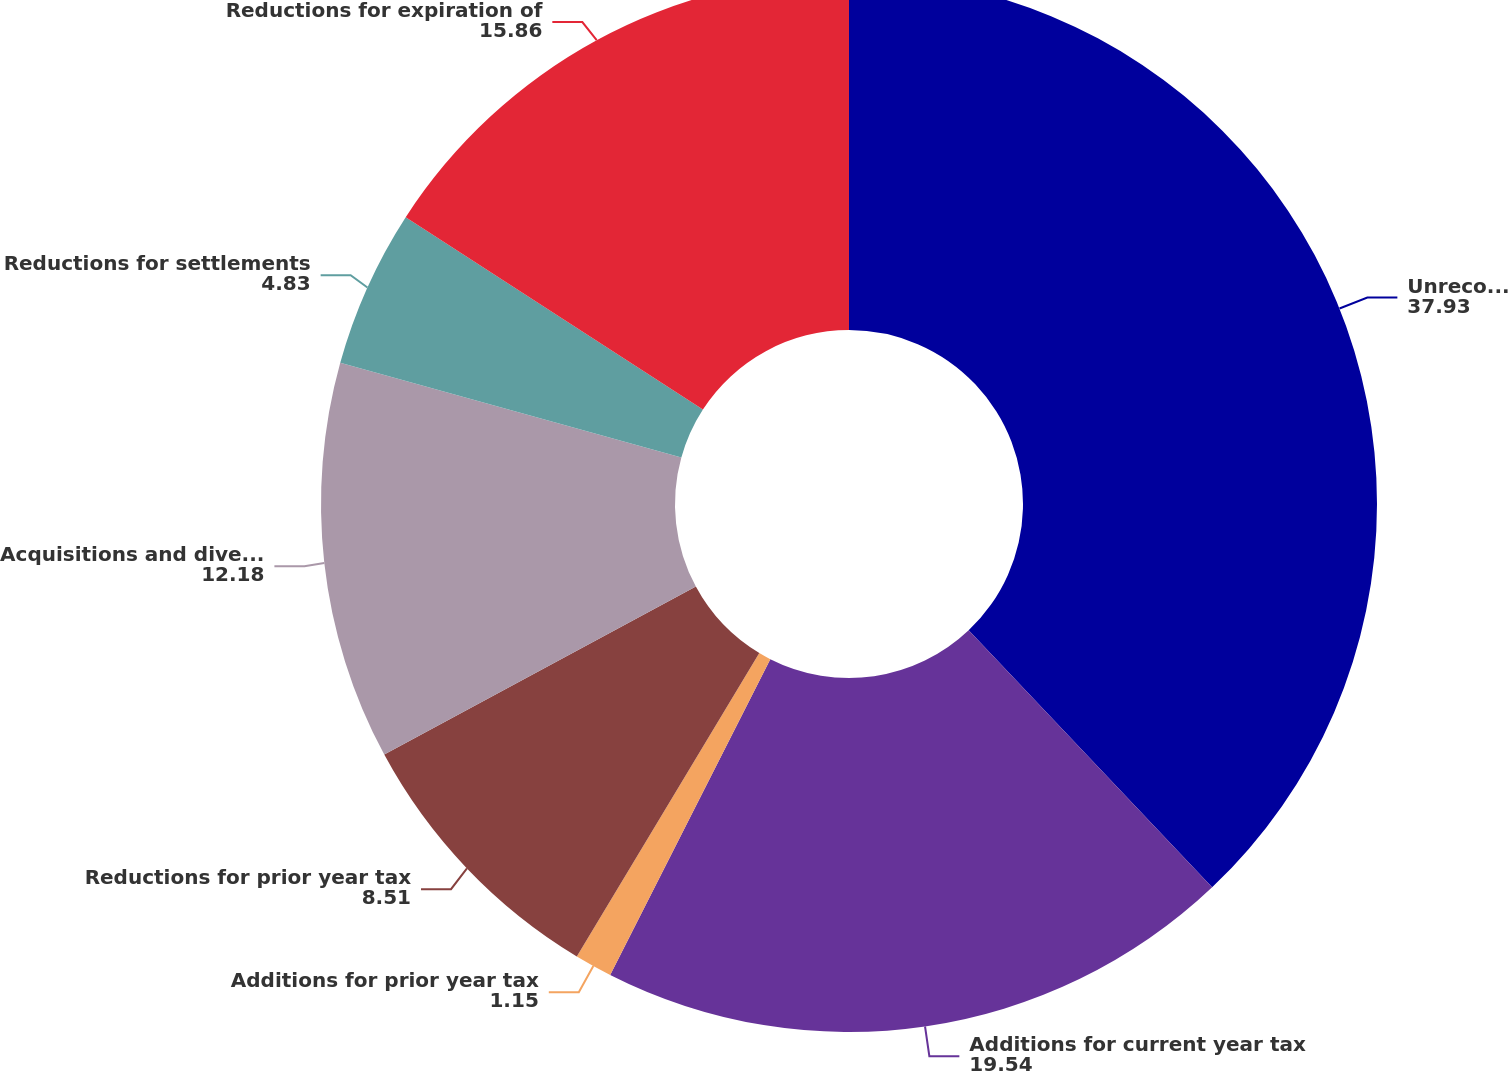<chart> <loc_0><loc_0><loc_500><loc_500><pie_chart><fcel>Unrecognized tax benefits<fcel>Additions for current year tax<fcel>Additions for prior year tax<fcel>Reductions for prior year tax<fcel>Acquisitions and divestitures<fcel>Reductions for settlements<fcel>Reductions for expiration of<nl><fcel>37.93%<fcel>19.54%<fcel>1.15%<fcel>8.51%<fcel>12.18%<fcel>4.83%<fcel>15.86%<nl></chart> 